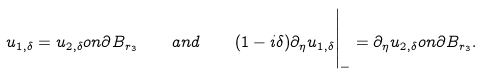Convert formula to latex. <formula><loc_0><loc_0><loc_500><loc_500>u _ { 1 , \delta } = u _ { 2 , \delta } o n \partial B _ { r _ { 3 } } \quad a n d \quad ( 1 - i \delta ) \partial _ { \eta } u _ { 1 , \delta } \Big | _ { - } = \partial _ { \eta } u _ { 2 , \delta } o n \partial B _ { r _ { 3 } } .</formula> 